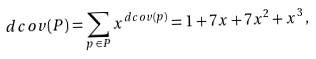<formula> <loc_0><loc_0><loc_500><loc_500>d c o v ( P ) = \sum _ { p \, \in \, P } x ^ { d c o v ( p ) } = 1 + 7 x + 7 x ^ { 2 } + x ^ { 3 } \, ,</formula> 